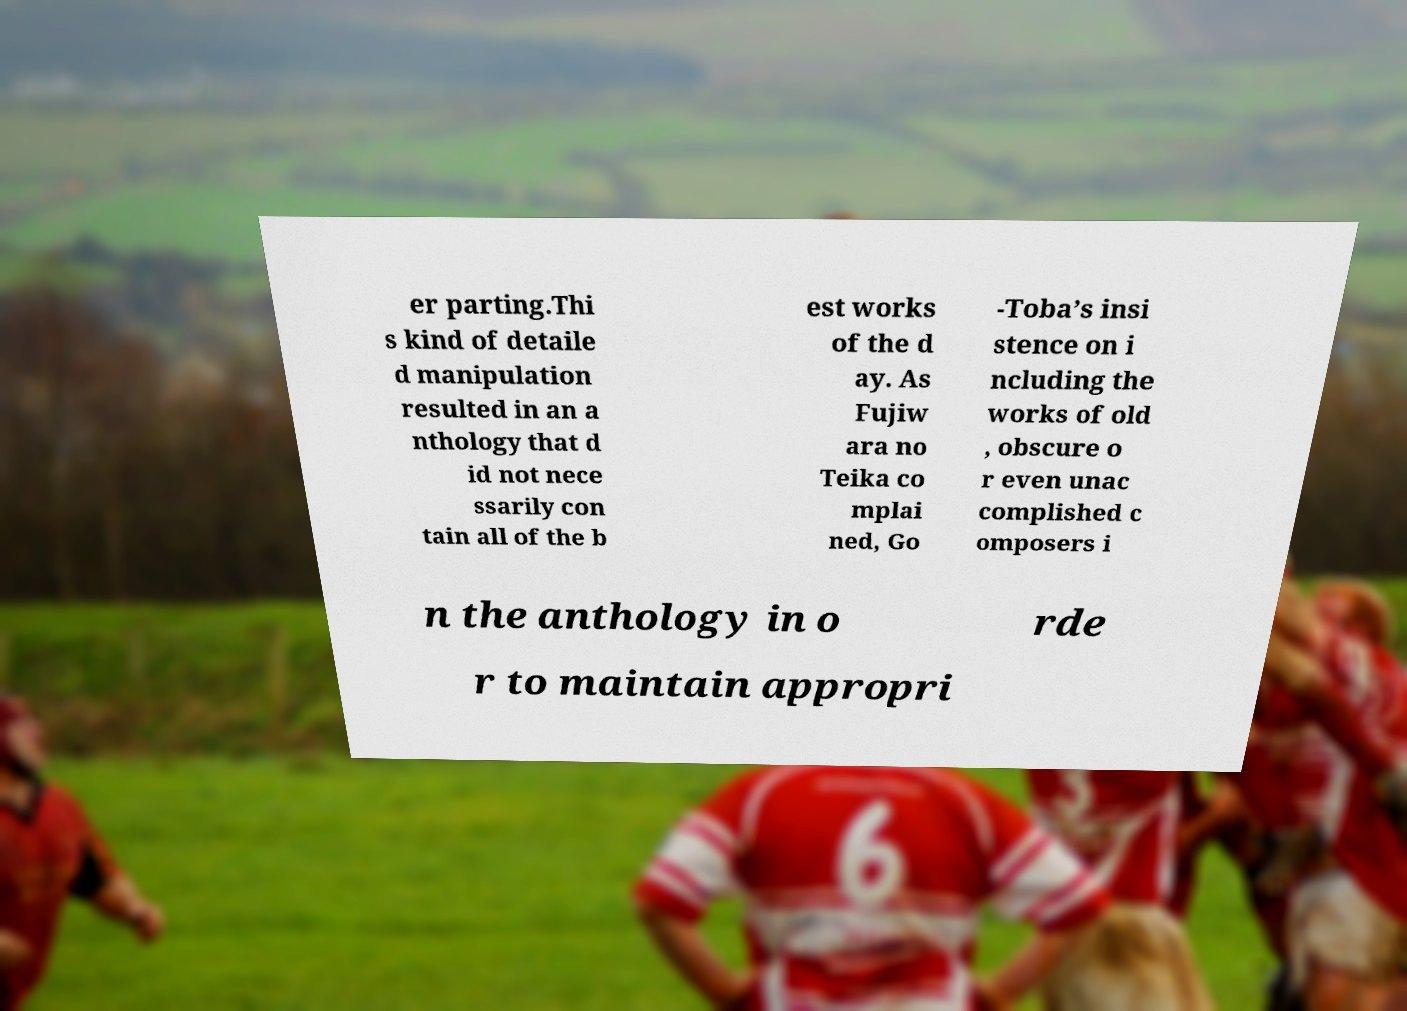I need the written content from this picture converted into text. Can you do that? er parting.Thi s kind of detaile d manipulation resulted in an a nthology that d id not nece ssarily con tain all of the b est works of the d ay. As Fujiw ara no Teika co mplai ned, Go -Toba’s insi stence on i ncluding the works of old , obscure o r even unac complished c omposers i n the anthology in o rde r to maintain appropri 